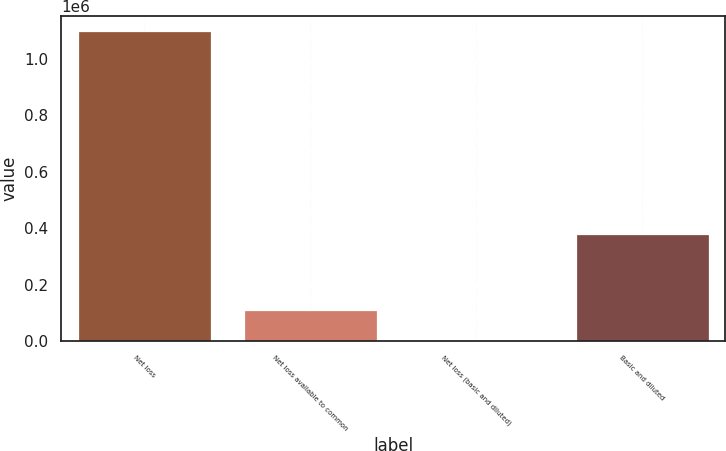Convert chart. <chart><loc_0><loc_0><loc_500><loc_500><bar_chart><fcel>Net loss<fcel>Net loss available to common<fcel>Net loss (basic and diluted)<fcel>Basic and diluted<nl><fcel>1.09673e+06<fcel>109676<fcel>2.9<fcel>378585<nl></chart> 